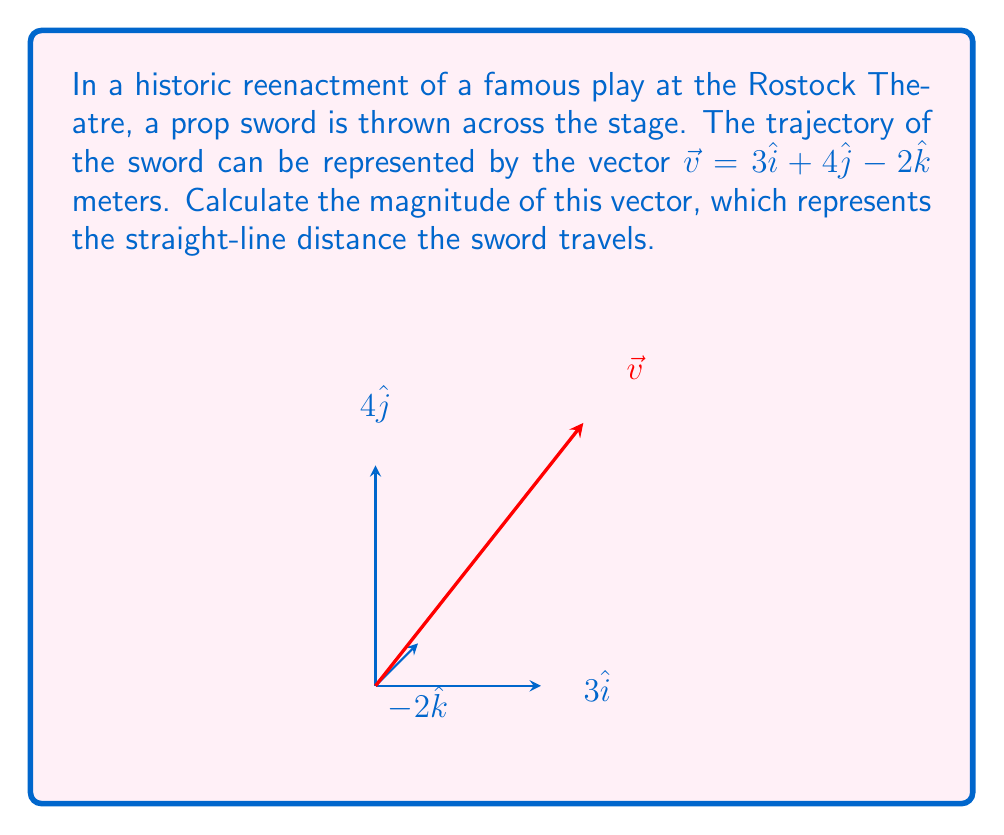Could you help me with this problem? To find the magnitude of the vector $\vec{v} = 3\hat{i} + 4\hat{j} - 2\hat{k}$, we use the formula:

$$ \|\vec{v}\| = \sqrt{x^2 + y^2 + z^2} $$

Where $x$, $y$, and $z$ are the components of the vector.

Step 1: Identify the components
$x = 3$
$y = 4$
$z = -2$

Step 2: Square each component
$x^2 = 3^2 = 9$
$y^2 = 4^2 = 16$
$z^2 = (-2)^2 = 4$

Step 3: Sum the squared components
$x^2 + y^2 + z^2 = 9 + 16 + 4 = 29$

Step 4: Take the square root of the sum
$\|\vec{v}\| = \sqrt{29}$

Therefore, the magnitude of the vector, which represents the straight-line distance the sword travels, is $\sqrt{29}$ meters.
Answer: $\sqrt{29}$ meters 